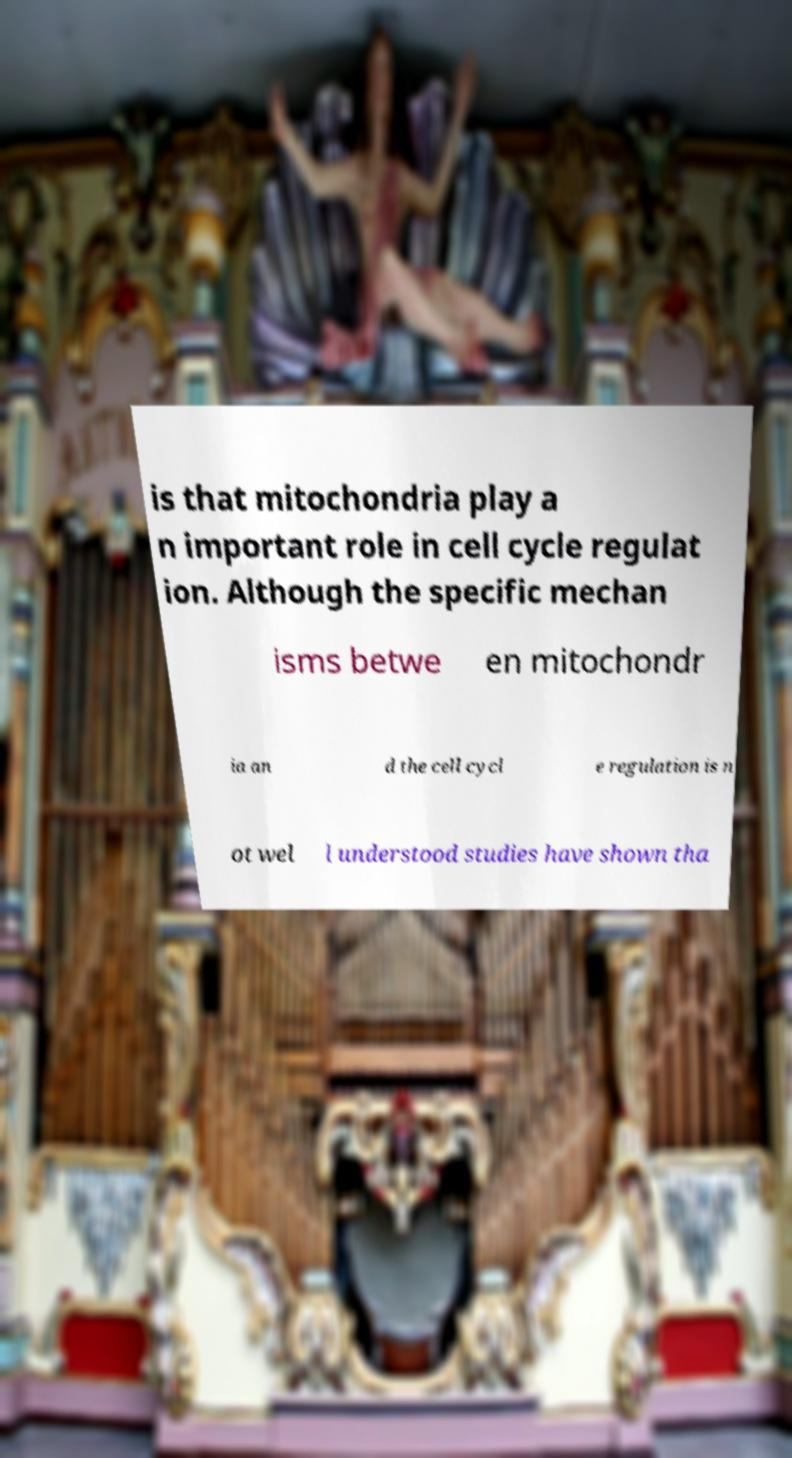There's text embedded in this image that I need extracted. Can you transcribe it verbatim? is that mitochondria play a n important role in cell cycle regulat ion. Although the specific mechan isms betwe en mitochondr ia an d the cell cycl e regulation is n ot wel l understood studies have shown tha 